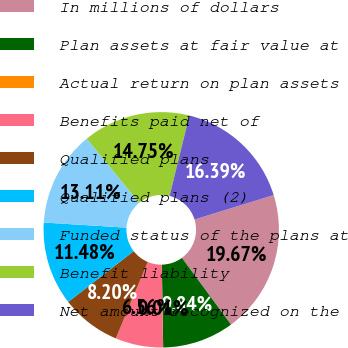<chart> <loc_0><loc_0><loc_500><loc_500><pie_chart><fcel>In millions of dollars<fcel>Plan assets at fair value at<fcel>Actual return on plan assets<fcel>Benefits paid net of<fcel>Qualified plans<fcel>Qualified plans (2)<fcel>Funded status of the plans at<fcel>Benefit liability<fcel>Net amount recognized on the<nl><fcel>19.67%<fcel>9.84%<fcel>0.01%<fcel>6.56%<fcel>8.2%<fcel>11.48%<fcel>13.11%<fcel>14.75%<fcel>16.39%<nl></chart> 